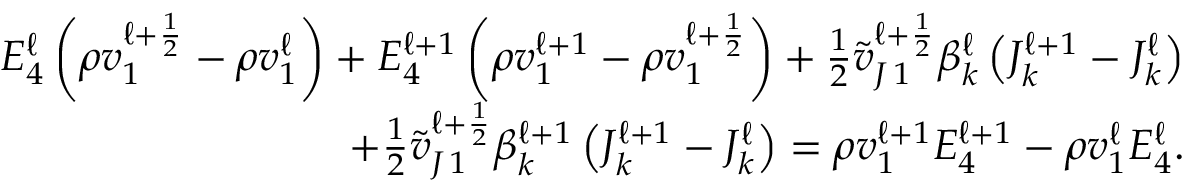<formula> <loc_0><loc_0><loc_500><loc_500>\begin{array} { r } { E _ { 4 } ^ { \ell } \left ( \rho v _ { 1 } ^ { \ell + \frac { 1 } { 2 } } - \rho v _ { 1 } ^ { \ell } \right ) + E _ { 4 } ^ { \ell + 1 } \left ( \rho v _ { 1 } ^ { \ell + 1 } - \rho v _ { 1 } ^ { \ell + \frac { 1 } { 2 } } \right ) + \frac { 1 } { 2 } \tilde { v } _ { J \, 1 } ^ { \ell + \frac { 1 } { 2 } } \beta _ { k } ^ { \ell } \left ( J _ { k } ^ { \ell + 1 } - J _ { k } ^ { \ell } \right ) } \\ { + \frac { 1 } { 2 } \tilde { v } _ { J \, 1 } ^ { \ell + \frac { 1 } { 2 } } \beta _ { k } ^ { \ell + 1 } \left ( J _ { k } ^ { \ell + 1 } - J _ { k } ^ { \ell } \right ) = \rho v _ { 1 } ^ { \ell + 1 } E _ { 4 } ^ { \ell + 1 } - \rho v _ { 1 } ^ { \ell } E _ { 4 } ^ { \ell } . } \end{array}</formula> 